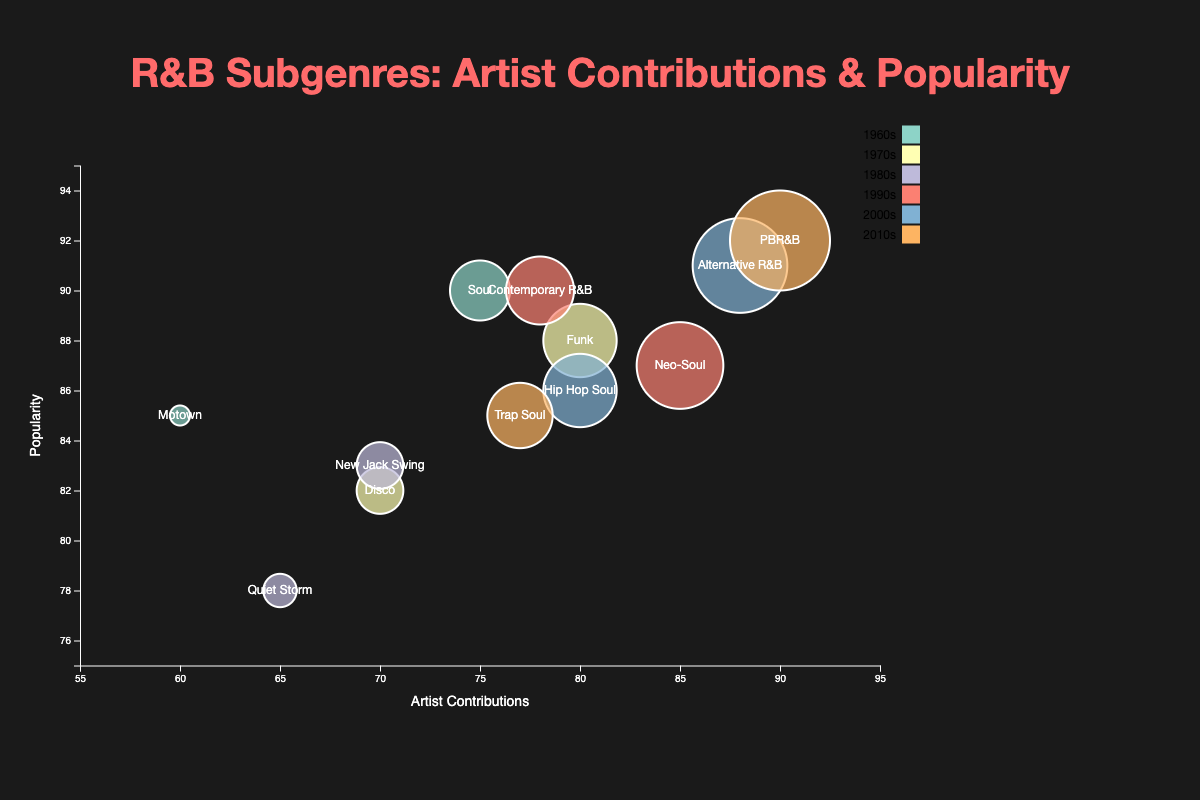What's the title of the chart? The title of the chart is written at the top of the figure and is displayed prominently.
Answer: R&B Subgenres: Artist Contributions & Popularity How many data points are shown for the 1980s? Look for all bubbles that correspond to the 1980s in the chart. There are two: "Quiet Storm" and "New Jack Swing".
Answer: 2 Which subgenre has the highest contribution in the 2010s? Identify the bubbles corresponding to the 2010s decade, and look at their contribution values. "PBR&B" by The Weeknd has the highest contribution with 90.
Answer: PBR&B What is the range of popularity values for the subgenres in the 1990s? Look for the popularity values of the two subgenres in the 1990s — "Neo-Soul" and "Contemporary R&B". The range is from 87 to 90.
Answer: 87-90 Name the artist with the highest contributions and specify their subgenre and decade. Identify the bubble with the largest contribution value and read the artist, subgenre, and decade labels. Frank Ocean with Alternative R&B in the 2000s has the highest contributions of 88.
Answer: Frank Ocean, Alternative R&B, 2000s How do the contributions of Aretha Franklin (1960s) and The Weeknd (2010s) compare? Identify the bubbles for Aretha Franklin in the 1960s and The Weeknd in the 2010s, then compare the contribution values. Aretha Franklin has 75 contributions, and The Weeknd has 90.
Answer: The Weeknd has 15 more contributions What is the median popularity of all subgenres represented in the chart? List all popularity values: 90, 85, 88, 82, 78, 83, 87, 90, 91, 86, 85, 92. Sort and find the middle value(s). Sorted: 78, 82, 83, 85, 85, 86, 87, 88, 90, 90, 91, 92. The median of 12 values is the average of the 6th and 7th values: (86 + 87) / 2 = 86.5.
Answer: 86.5 Which subgenre has the least popularity, and which decade does it belong to? Spot the bubble with the smallest popularity value, and note its subgenre and decade. "Quiet Storm" by Anita Baker in the 1980s has the least popularity with 78.
Answer: Quiet Storm, 1980s 